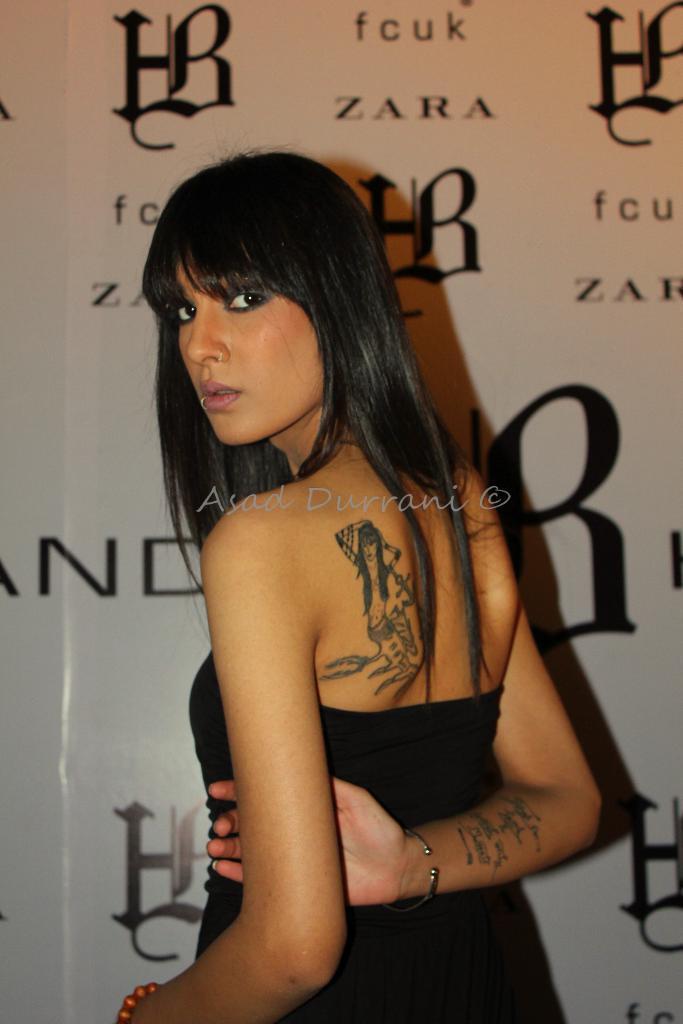Please provide a concise description of this image. In the picture we can see a woman wearing black dress has turned back where we can see tattoos on her back shoulder and on her hand. In the background, we can see the white color banner on which we can see some text. Here we can see the watermark in the center of the image. 